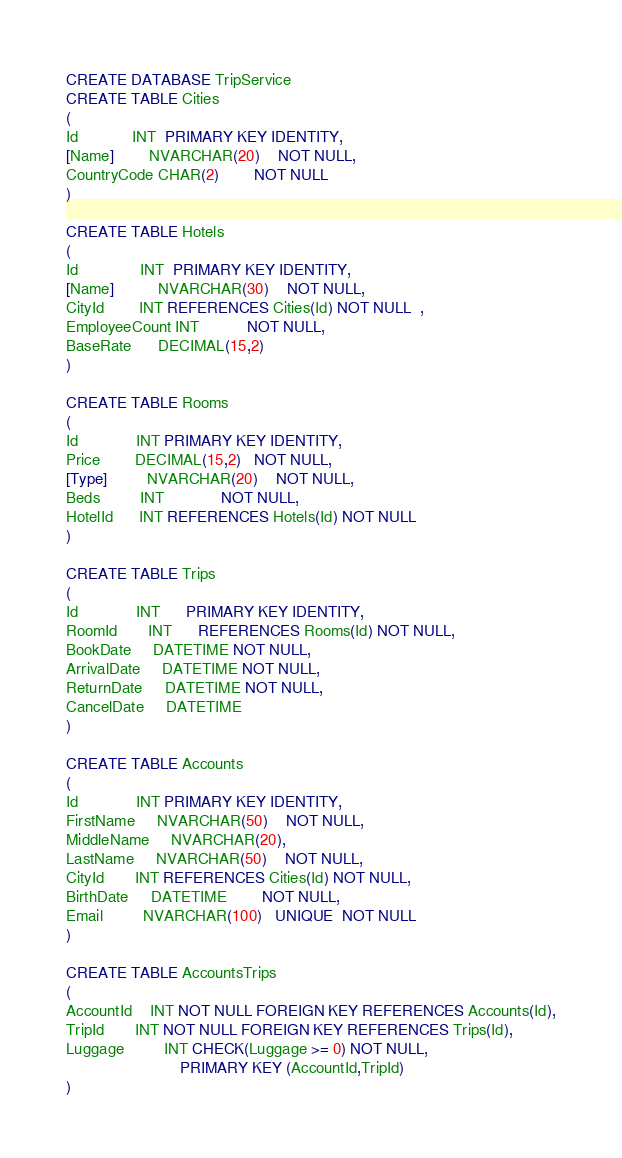Convert code to text. <code><loc_0><loc_0><loc_500><loc_500><_SQL_>CREATE DATABASE TripService
CREATE TABLE Cities
(
Id			INT  PRIMARY KEY IDENTITY,
[Name]		NVARCHAR(20)    NOT NULL,
CountryCode CHAR(2)        NOT NULL
)

CREATE TABLE Hotels
(
Id			  INT  PRIMARY KEY IDENTITY,
[Name]		  NVARCHAR(30)    NOT NULL,
CityId        INT REFERENCES Cities(Id) NOT NULL  ,
EmployeeCount INT           NOT NULL,
BaseRate      DECIMAL(15,2)  
)

CREATE TABLE Rooms
(
Id			 INT PRIMARY KEY IDENTITY,
Price        DECIMAL(15,2)   NOT NULL,
[Type]		 NVARCHAR(20)    NOT NULL,
Beds		 INT             NOT NULL,
HotelId      INT REFERENCES Hotels(Id) NOT NULL 
)

CREATE TABLE Trips
(
Id			 INT	  PRIMARY KEY IDENTITY,
RoomId       INT      REFERENCES Rooms(Id) NOT NULL,
BookDate	 DATETIME NOT NULL,
ArrivalDate	 DATETIME NOT NULL,
ReturnDate	 DATETIME NOT NULL, 
CancelDate	 DATETIME
)

CREATE TABLE Accounts
(
Id			 INT PRIMARY KEY IDENTITY,
FirstName	 NVARCHAR(50)    NOT NULL,
MiddleName	 NVARCHAR(20),
LastName	 NVARCHAR(50)    NOT NULL,
CityId       INT REFERENCES Cities(Id) NOT NULL,
BirthDate	 DATETIME        NOT NULL, 
Email	     NVARCHAR(100)   UNIQUE  NOT NULL 
)

CREATE TABLE AccountsTrips
(
AccountId    INT NOT NULL FOREIGN KEY REFERENCES Accounts(Id),
TripId       INT NOT NULL FOREIGN KEY REFERENCES Trips(Id),
Luggage	     INT CHECK(Luggage >= 0) NOT NULL,
		                  PRIMARY KEY (AccountId,TripId)
)</code> 